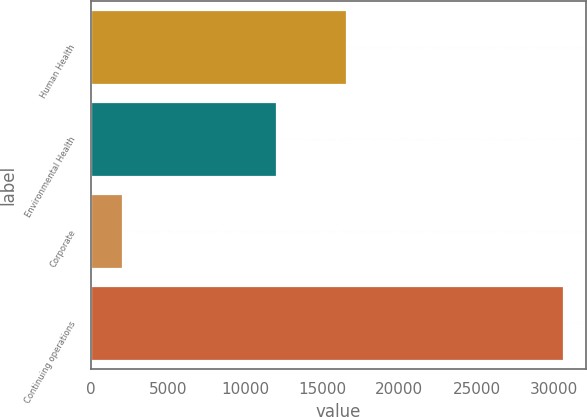<chart> <loc_0><loc_0><loc_500><loc_500><bar_chart><fcel>Human Health<fcel>Environmental Health<fcel>Corporate<fcel>Continuing operations<nl><fcel>16570<fcel>12015<fcel>2007<fcel>30592<nl></chart> 